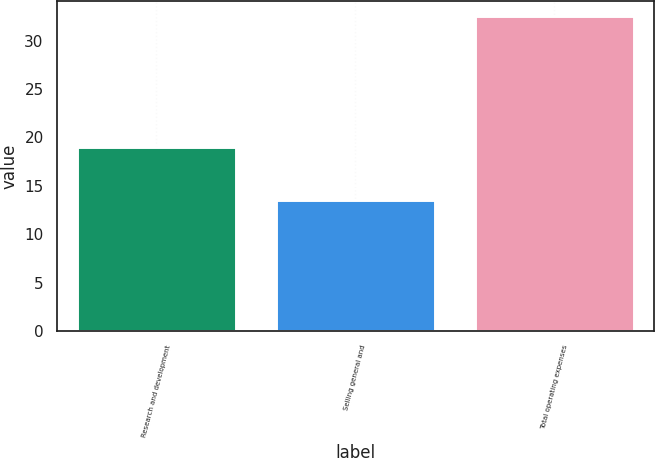Convert chart. <chart><loc_0><loc_0><loc_500><loc_500><bar_chart><fcel>Research and development<fcel>Selling general and<fcel>Total operating expenses<nl><fcel>19<fcel>13.5<fcel>32.5<nl></chart> 